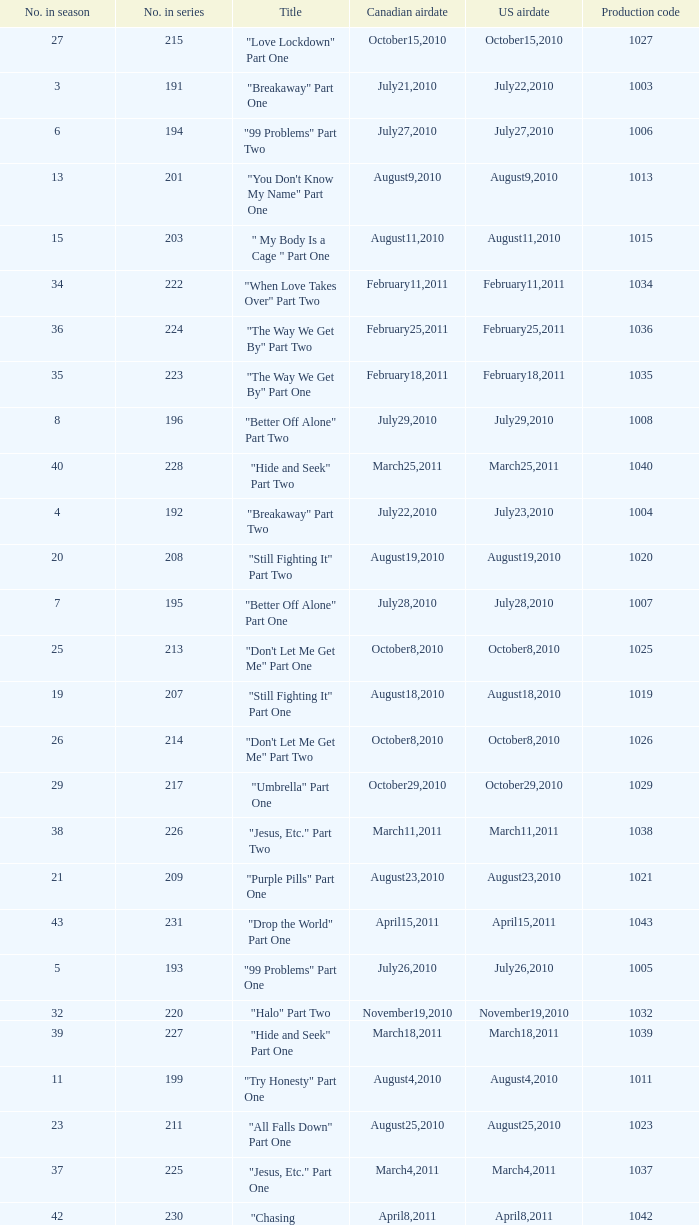What was the us airdate of "love lockdown" part one? October15,2010. 